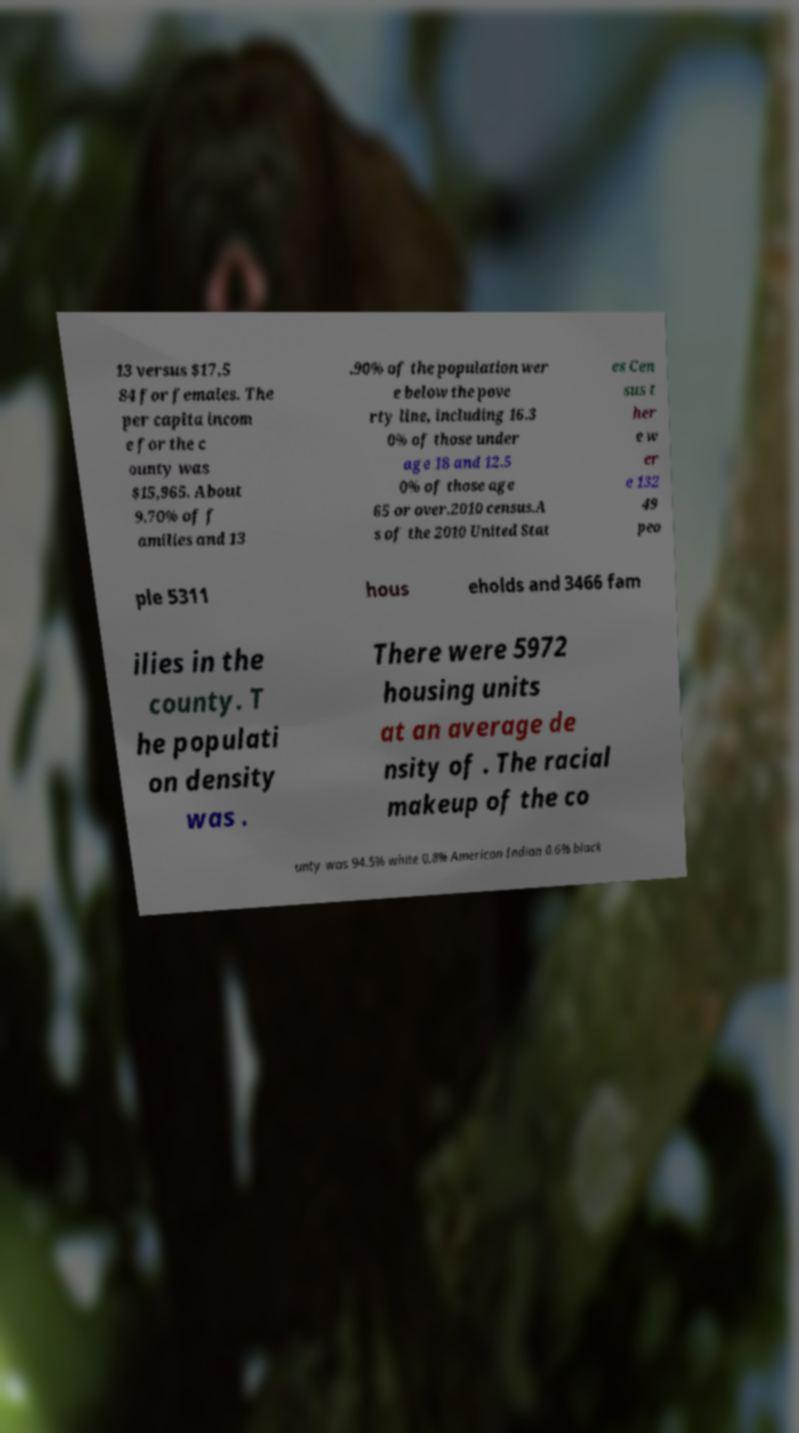Can you accurately transcribe the text from the provided image for me? 13 versus $17,5 84 for females. The per capita incom e for the c ounty was $15,965. About 9.70% of f amilies and 13 .90% of the population wer e below the pove rty line, including 16.3 0% of those under age 18 and 12.5 0% of those age 65 or over.2010 census.A s of the 2010 United Stat es Cen sus t her e w er e 132 49 peo ple 5311 hous eholds and 3466 fam ilies in the county. T he populati on density was . There were 5972 housing units at an average de nsity of . The racial makeup of the co unty was 94.5% white 0.8% American Indian 0.6% black 